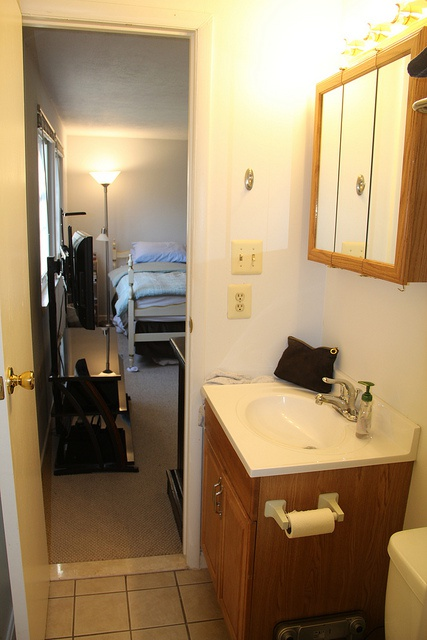Describe the objects in this image and their specific colors. I can see sink in tan and olive tones, bed in tan, darkgray, gray, and black tones, toilet in tan and olive tones, handbag in tan, black, maroon, and gray tones, and tv in tan, black, maroon, gray, and darkgray tones in this image. 